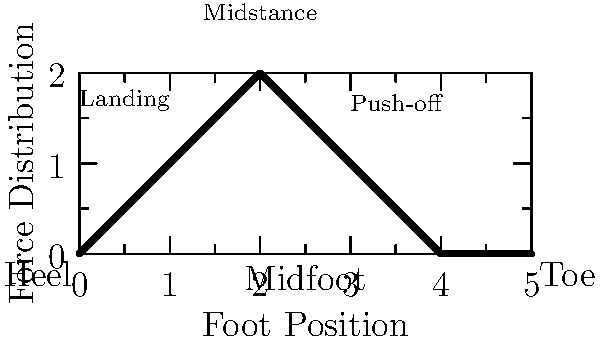As a student-athlete, you're analyzing the force distribution on a runner's foot during different phases of a stride. Based on the heat map provided, which phase of the stride experiences the highest force concentration, and where is it located on the foot? To answer this question, we need to analyze the heat map and understand the different phases of a runner's stride:

1. The x-axis represents the foot position from heel to toe.
2. The y-axis represents the force distribution.
3. The colors indicate the intensity of force, with red being the highest and blue the lowest.

Analyzing the phases:

1. Landing phase (initial contact):
   - Located at the left side of the graph
   - Shows moderate force concentration (light blue to green)
   - Primarily on the heel area

2. Midstance phase:
   - Located in the middle of the graph
   - Displays the highest force concentration (yellow to red)
   - Centered around the midfoot area

3. Push-off phase:
   - Located on the right side of the graph
   - Shows decreasing force (green to blue)
   - Mainly in the toe area

Comparing the colors and heights of the graph, we can see that the midstance phase has the highest point and the most intense color (red), indicating the highest force concentration. This occurs in the midfoot area of the runner's foot.
Answer: Midstance phase, midfoot area 